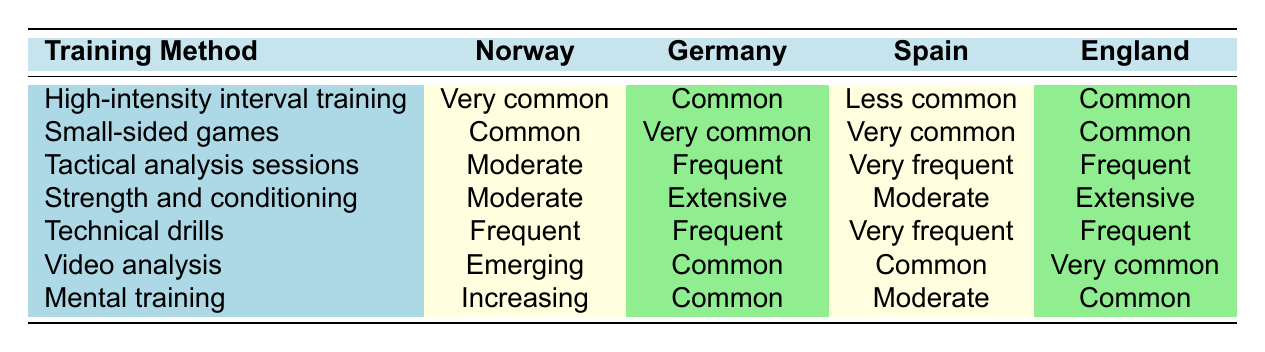What training method is described as 'Very common' in Norway? According to the table, the training method 'High-intensity interval training' is noted as 'Very common' in Norway.
Answer: High-intensity interval training Which training method is 'Very frequent' in Spain? The method 'Tactical analysis sessions' is listed as 'Very frequent' for Spain in the table.
Answer: Tactical analysis sessions Is strength and conditioning training extensively used in Norway? In the table, 'Strength and conditioning' is marked as 'Moderate' in Norway, which indicates it is not extensively used there.
Answer: No In which country is video analysis the most common? The data shows that 'Video analysis' is 'Very common' in England, making it the country where this method is the most common.
Answer: England How many training methods are considered 'Very common' in Germany? The table shows that there are two training methods marked as 'Very common' in Germany: 'Small-sided games' and 'High-intensity interval training'.
Answer: 2 Which training method has the least common usage in Spain? The data indicates that 'High-intensity interval training' is described as 'Less common' in Spain, which is the lowest frequency noted in the table for that country.
Answer: High-intensity interval training Which country's approach to mental training is described as 'Increasing'? The table specifies that Norway's approach to 'Mental training' is described as 'Increasing'.
Answer: Norway How does the frequency of small-sided games compare between Norway and Germany? The table states 'Small-sided games' are 'Common' in Norway and 'Very common' in Germany, indicating that Germany uses this method more frequently.
Answer: Germany uses it more frequently than Norway What is the difference in usage of technical drills between Norway and Spain? In Norway, 'Technical drills' are 'Frequent', while in Spain they are 'Very frequent', showing Spain utilizes this method more frequently than Norway.
Answer: Spain uses it more frequently than Norway 